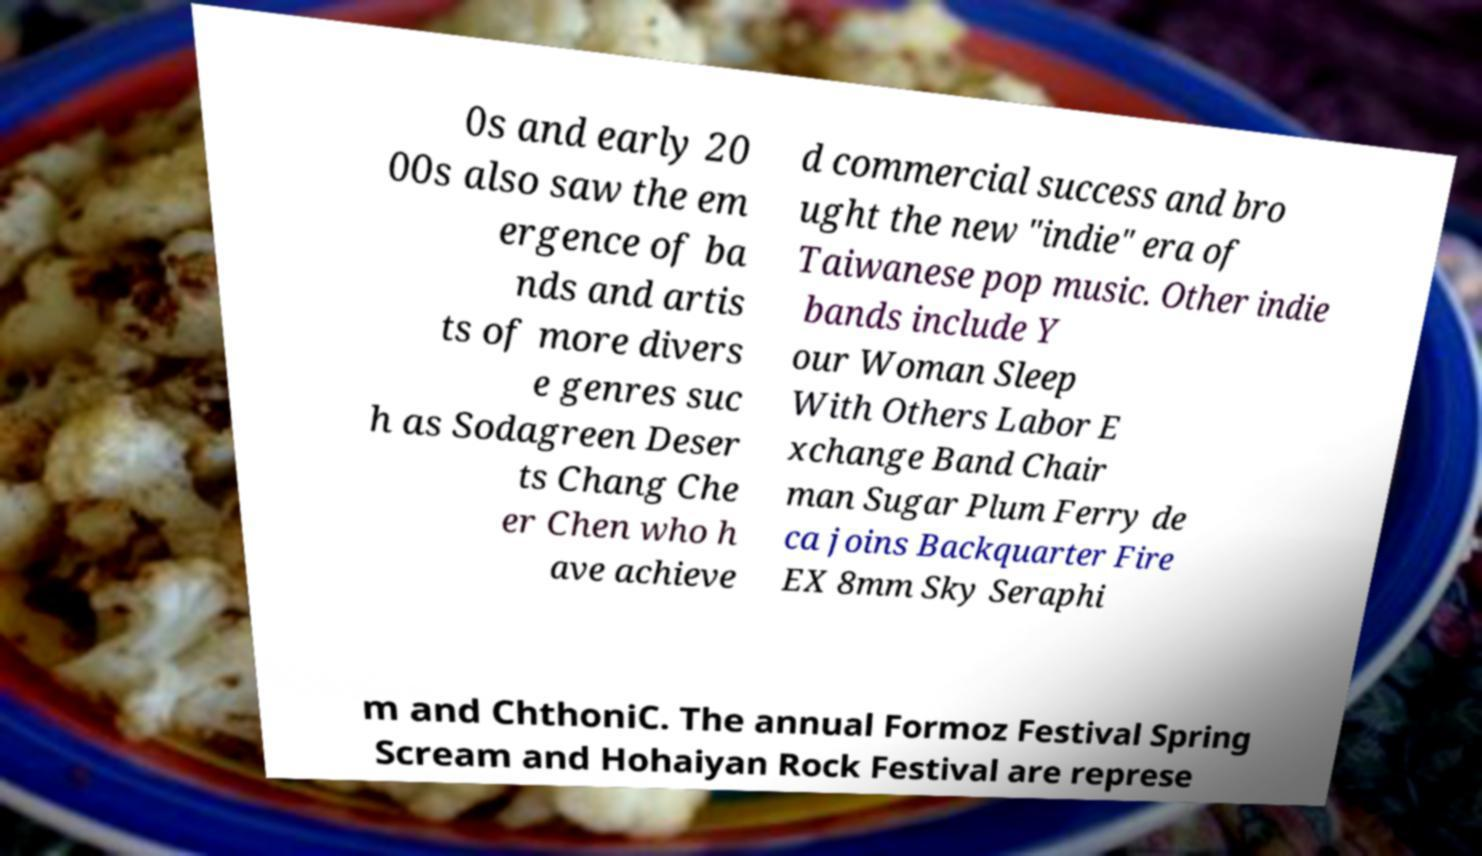For documentation purposes, I need the text within this image transcribed. Could you provide that? 0s and early 20 00s also saw the em ergence of ba nds and artis ts of more divers e genres suc h as Sodagreen Deser ts Chang Che er Chen who h ave achieve d commercial success and bro ught the new "indie" era of Taiwanese pop music. Other indie bands include Y our Woman Sleep With Others Labor E xchange Band Chair man Sugar Plum Ferry de ca joins Backquarter Fire EX 8mm Sky Seraphi m and ChthoniC. The annual Formoz Festival Spring Scream and Hohaiyan Rock Festival are represe 